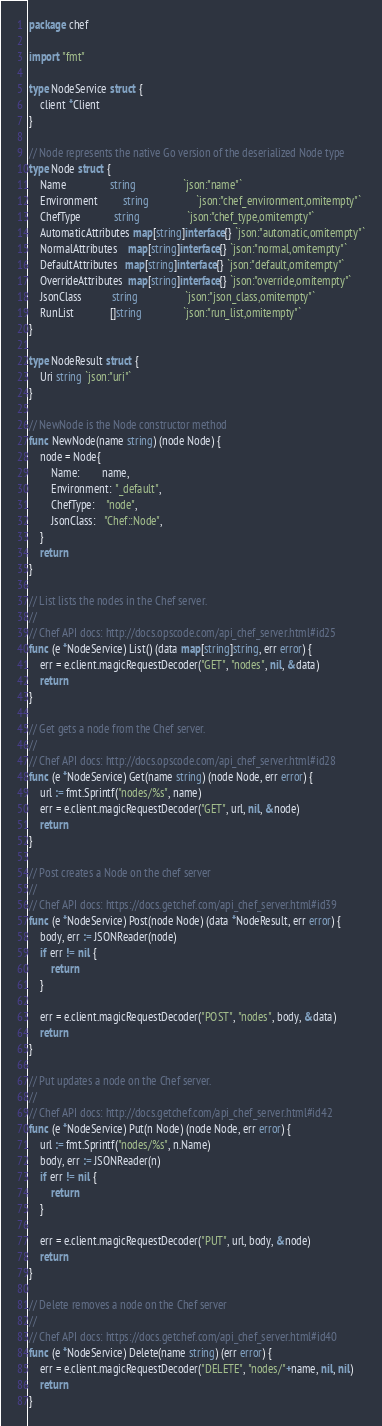Convert code to text. <code><loc_0><loc_0><loc_500><loc_500><_Go_>package chef

import "fmt"

type NodeService struct {
	client *Client
}

// Node represents the native Go version of the deserialized Node type
type Node struct {
	Name                string                 `json:"name"`
	Environment         string                 `json:"chef_environment,omitempty"`
	ChefType            string                 `json:"chef_type,omitempty"`
	AutomaticAttributes map[string]interface{} `json:"automatic,omitempty"`
	NormalAttributes    map[string]interface{} `json:"normal,omitempty"`
	DefaultAttributes   map[string]interface{} `json:"default,omitempty"`
	OverrideAttributes  map[string]interface{} `json:"override,omitempty"`
	JsonClass           string                 `json:"json_class,omitempty"`
	RunList             []string               `json:"run_list,omitempty"`
}

type NodeResult struct {
	Uri string `json:"uri"`
}

// NewNode is the Node constructor method
func NewNode(name string) (node Node) {
	node = Node{
		Name:        name,
		Environment: "_default",
		ChefType:    "node",
		JsonClass:   "Chef::Node",
	}
	return
}

// List lists the nodes in the Chef server.
//
// Chef API docs: http://docs.opscode.com/api_chef_server.html#id25
func (e *NodeService) List() (data map[string]string, err error) {
	err = e.client.magicRequestDecoder("GET", "nodes", nil, &data)
	return
}

// Get gets a node from the Chef server.
//
// Chef API docs: http://docs.opscode.com/api_chef_server.html#id28
func (e *NodeService) Get(name string) (node Node, err error) {
	url := fmt.Sprintf("nodes/%s", name)
	err = e.client.magicRequestDecoder("GET", url, nil, &node)
	return
}

// Post creates a Node on the chef server
//
// Chef API docs: https://docs.getchef.com/api_chef_server.html#id39
func (e *NodeService) Post(node Node) (data *NodeResult, err error) {
	body, err := JSONReader(node)
	if err != nil {
		return
	}

	err = e.client.magicRequestDecoder("POST", "nodes", body, &data)
	return
}

// Put updates a node on the Chef server.
//
// Chef API docs: http://docs.getchef.com/api_chef_server.html#id42
func (e *NodeService) Put(n Node) (node Node, err error) {
	url := fmt.Sprintf("nodes/%s", n.Name)
	body, err := JSONReader(n)
	if err != nil {
		return
	}

	err = e.client.magicRequestDecoder("PUT", url, body, &node)
	return
}

// Delete removes a node on the Chef server
//
// Chef API docs: https://docs.getchef.com/api_chef_server.html#id40
func (e *NodeService) Delete(name string) (err error) {
	err = e.client.magicRequestDecoder("DELETE", "nodes/"+name, nil, nil)
	return
}
</code> 